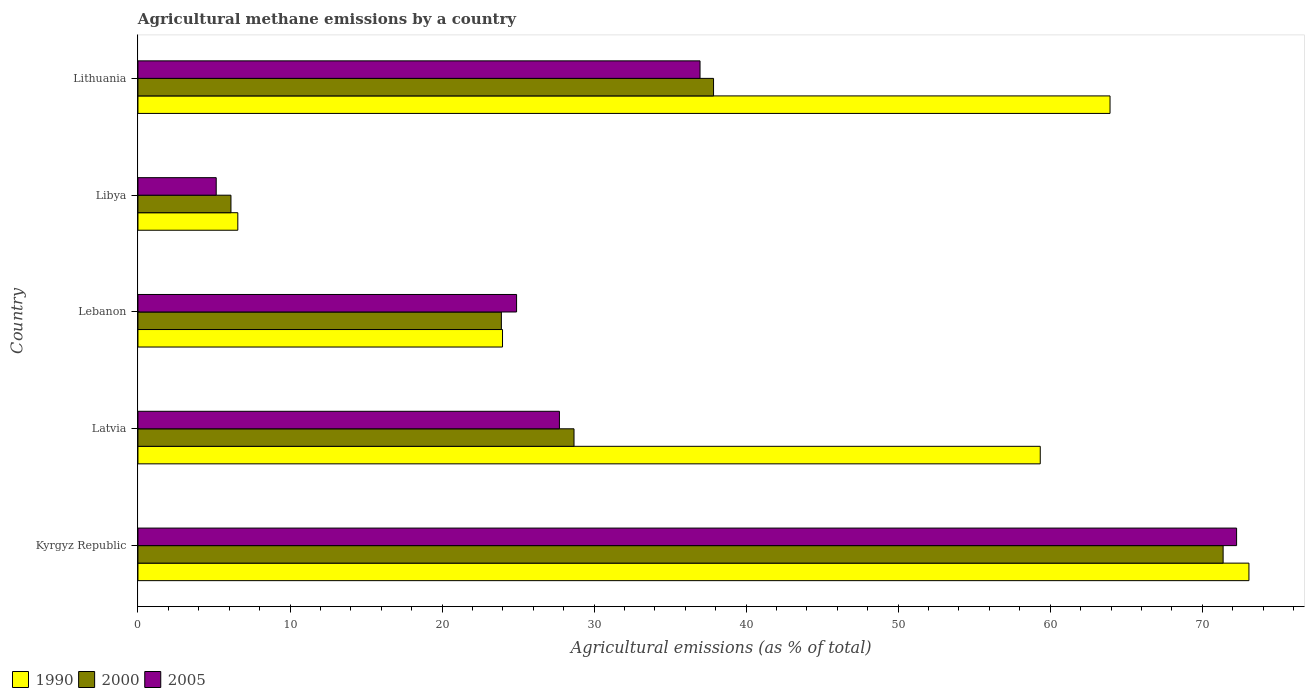How many different coloured bars are there?
Your answer should be very brief. 3. How many bars are there on the 4th tick from the bottom?
Provide a succinct answer. 3. What is the label of the 3rd group of bars from the top?
Make the answer very short. Lebanon. In how many cases, is the number of bars for a given country not equal to the number of legend labels?
Offer a very short reply. 0. What is the amount of agricultural methane emitted in 2000 in Latvia?
Your answer should be compact. 28.68. Across all countries, what is the maximum amount of agricultural methane emitted in 2000?
Ensure brevity in your answer.  71.37. Across all countries, what is the minimum amount of agricultural methane emitted in 2005?
Make the answer very short. 5.15. In which country was the amount of agricultural methane emitted in 1990 maximum?
Keep it short and to the point. Kyrgyz Republic. In which country was the amount of agricultural methane emitted in 2005 minimum?
Provide a succinct answer. Libya. What is the total amount of agricultural methane emitted in 2000 in the graph?
Your response must be concise. 167.93. What is the difference between the amount of agricultural methane emitted in 2000 in Lebanon and that in Lithuania?
Provide a succinct answer. -13.95. What is the difference between the amount of agricultural methane emitted in 1990 in Lithuania and the amount of agricultural methane emitted in 2005 in Latvia?
Make the answer very short. 36.21. What is the average amount of agricultural methane emitted in 1990 per country?
Offer a very short reply. 45.38. What is the difference between the amount of agricultural methane emitted in 2005 and amount of agricultural methane emitted in 1990 in Lebanon?
Offer a terse response. 0.93. In how many countries, is the amount of agricultural methane emitted in 2005 greater than 62 %?
Your response must be concise. 1. What is the ratio of the amount of agricultural methane emitted in 2000 in Kyrgyz Republic to that in Lithuania?
Your answer should be compact. 1.89. Is the difference between the amount of agricultural methane emitted in 2005 in Libya and Lithuania greater than the difference between the amount of agricultural methane emitted in 1990 in Libya and Lithuania?
Your response must be concise. Yes. What is the difference between the highest and the second highest amount of agricultural methane emitted in 2005?
Ensure brevity in your answer.  35.29. What is the difference between the highest and the lowest amount of agricultural methane emitted in 2005?
Ensure brevity in your answer.  67.11. In how many countries, is the amount of agricultural methane emitted in 1990 greater than the average amount of agricultural methane emitted in 1990 taken over all countries?
Give a very brief answer. 3. What does the 1st bar from the top in Latvia represents?
Your answer should be compact. 2005. What does the 1st bar from the bottom in Lithuania represents?
Keep it short and to the point. 1990. Is it the case that in every country, the sum of the amount of agricultural methane emitted in 2000 and amount of agricultural methane emitted in 2005 is greater than the amount of agricultural methane emitted in 1990?
Your answer should be very brief. No. How many bars are there?
Provide a short and direct response. 15. Are the values on the major ticks of X-axis written in scientific E-notation?
Your answer should be compact. No. Where does the legend appear in the graph?
Offer a terse response. Bottom left. How many legend labels are there?
Provide a short and direct response. 3. What is the title of the graph?
Provide a short and direct response. Agricultural methane emissions by a country. Does "1993" appear as one of the legend labels in the graph?
Give a very brief answer. No. What is the label or title of the X-axis?
Make the answer very short. Agricultural emissions (as % of total). What is the Agricultural emissions (as % of total) of 1990 in Kyrgyz Republic?
Provide a succinct answer. 73.07. What is the Agricultural emissions (as % of total) of 2000 in Kyrgyz Republic?
Ensure brevity in your answer.  71.37. What is the Agricultural emissions (as % of total) of 2005 in Kyrgyz Republic?
Your answer should be compact. 72.26. What is the Agricultural emissions (as % of total) in 1990 in Latvia?
Your answer should be very brief. 59.34. What is the Agricultural emissions (as % of total) in 2000 in Latvia?
Your answer should be very brief. 28.68. What is the Agricultural emissions (as % of total) in 2005 in Latvia?
Offer a terse response. 27.72. What is the Agricultural emissions (as % of total) of 1990 in Lebanon?
Provide a short and direct response. 23.98. What is the Agricultural emissions (as % of total) of 2000 in Lebanon?
Your response must be concise. 23.9. What is the Agricultural emissions (as % of total) in 2005 in Lebanon?
Provide a short and direct response. 24.9. What is the Agricultural emissions (as % of total) in 1990 in Libya?
Offer a very short reply. 6.57. What is the Agricultural emissions (as % of total) in 2000 in Libya?
Keep it short and to the point. 6.12. What is the Agricultural emissions (as % of total) of 2005 in Libya?
Ensure brevity in your answer.  5.15. What is the Agricultural emissions (as % of total) in 1990 in Lithuania?
Keep it short and to the point. 63.93. What is the Agricultural emissions (as % of total) in 2000 in Lithuania?
Make the answer very short. 37.86. What is the Agricultural emissions (as % of total) in 2005 in Lithuania?
Offer a very short reply. 36.97. Across all countries, what is the maximum Agricultural emissions (as % of total) of 1990?
Provide a succinct answer. 73.07. Across all countries, what is the maximum Agricultural emissions (as % of total) of 2000?
Your response must be concise. 71.37. Across all countries, what is the maximum Agricultural emissions (as % of total) in 2005?
Offer a terse response. 72.26. Across all countries, what is the minimum Agricultural emissions (as % of total) in 1990?
Offer a very short reply. 6.57. Across all countries, what is the minimum Agricultural emissions (as % of total) of 2000?
Give a very brief answer. 6.12. Across all countries, what is the minimum Agricultural emissions (as % of total) in 2005?
Give a very brief answer. 5.15. What is the total Agricultural emissions (as % of total) of 1990 in the graph?
Provide a short and direct response. 226.89. What is the total Agricultural emissions (as % of total) in 2000 in the graph?
Your answer should be compact. 167.93. What is the total Agricultural emissions (as % of total) in 2005 in the graph?
Your answer should be very brief. 167. What is the difference between the Agricultural emissions (as % of total) of 1990 in Kyrgyz Republic and that in Latvia?
Give a very brief answer. 13.73. What is the difference between the Agricultural emissions (as % of total) in 2000 in Kyrgyz Republic and that in Latvia?
Provide a succinct answer. 42.69. What is the difference between the Agricultural emissions (as % of total) of 2005 in Kyrgyz Republic and that in Latvia?
Your response must be concise. 44.54. What is the difference between the Agricultural emissions (as % of total) in 1990 in Kyrgyz Republic and that in Lebanon?
Ensure brevity in your answer.  49.09. What is the difference between the Agricultural emissions (as % of total) in 2000 in Kyrgyz Republic and that in Lebanon?
Provide a short and direct response. 47.47. What is the difference between the Agricultural emissions (as % of total) of 2005 in Kyrgyz Republic and that in Lebanon?
Make the answer very short. 47.36. What is the difference between the Agricultural emissions (as % of total) in 1990 in Kyrgyz Republic and that in Libya?
Offer a terse response. 66.5. What is the difference between the Agricultural emissions (as % of total) of 2000 in Kyrgyz Republic and that in Libya?
Your response must be concise. 65.26. What is the difference between the Agricultural emissions (as % of total) of 2005 in Kyrgyz Republic and that in Libya?
Offer a very short reply. 67.11. What is the difference between the Agricultural emissions (as % of total) in 1990 in Kyrgyz Republic and that in Lithuania?
Your response must be concise. 9.14. What is the difference between the Agricultural emissions (as % of total) in 2000 in Kyrgyz Republic and that in Lithuania?
Ensure brevity in your answer.  33.52. What is the difference between the Agricultural emissions (as % of total) of 2005 in Kyrgyz Republic and that in Lithuania?
Provide a succinct answer. 35.29. What is the difference between the Agricultural emissions (as % of total) of 1990 in Latvia and that in Lebanon?
Keep it short and to the point. 35.37. What is the difference between the Agricultural emissions (as % of total) of 2000 in Latvia and that in Lebanon?
Provide a short and direct response. 4.78. What is the difference between the Agricultural emissions (as % of total) in 2005 in Latvia and that in Lebanon?
Keep it short and to the point. 2.82. What is the difference between the Agricultural emissions (as % of total) of 1990 in Latvia and that in Libya?
Your response must be concise. 52.78. What is the difference between the Agricultural emissions (as % of total) in 2000 in Latvia and that in Libya?
Your response must be concise. 22.56. What is the difference between the Agricultural emissions (as % of total) of 2005 in Latvia and that in Libya?
Provide a short and direct response. 22.57. What is the difference between the Agricultural emissions (as % of total) in 1990 in Latvia and that in Lithuania?
Offer a very short reply. -4.59. What is the difference between the Agricultural emissions (as % of total) of 2000 in Latvia and that in Lithuania?
Offer a very short reply. -9.18. What is the difference between the Agricultural emissions (as % of total) of 2005 in Latvia and that in Lithuania?
Offer a terse response. -9.25. What is the difference between the Agricultural emissions (as % of total) in 1990 in Lebanon and that in Libya?
Your answer should be very brief. 17.41. What is the difference between the Agricultural emissions (as % of total) of 2000 in Lebanon and that in Libya?
Offer a very short reply. 17.79. What is the difference between the Agricultural emissions (as % of total) in 2005 in Lebanon and that in Libya?
Give a very brief answer. 19.76. What is the difference between the Agricultural emissions (as % of total) in 1990 in Lebanon and that in Lithuania?
Keep it short and to the point. -39.96. What is the difference between the Agricultural emissions (as % of total) of 2000 in Lebanon and that in Lithuania?
Offer a very short reply. -13.95. What is the difference between the Agricultural emissions (as % of total) in 2005 in Lebanon and that in Lithuania?
Your answer should be very brief. -12.07. What is the difference between the Agricultural emissions (as % of total) in 1990 in Libya and that in Lithuania?
Ensure brevity in your answer.  -57.37. What is the difference between the Agricultural emissions (as % of total) in 2000 in Libya and that in Lithuania?
Keep it short and to the point. -31.74. What is the difference between the Agricultural emissions (as % of total) of 2005 in Libya and that in Lithuania?
Your answer should be very brief. -31.82. What is the difference between the Agricultural emissions (as % of total) of 1990 in Kyrgyz Republic and the Agricultural emissions (as % of total) of 2000 in Latvia?
Your answer should be very brief. 44.39. What is the difference between the Agricultural emissions (as % of total) in 1990 in Kyrgyz Republic and the Agricultural emissions (as % of total) in 2005 in Latvia?
Your response must be concise. 45.35. What is the difference between the Agricultural emissions (as % of total) in 2000 in Kyrgyz Republic and the Agricultural emissions (as % of total) in 2005 in Latvia?
Your answer should be compact. 43.65. What is the difference between the Agricultural emissions (as % of total) of 1990 in Kyrgyz Republic and the Agricultural emissions (as % of total) of 2000 in Lebanon?
Ensure brevity in your answer.  49.17. What is the difference between the Agricultural emissions (as % of total) in 1990 in Kyrgyz Republic and the Agricultural emissions (as % of total) in 2005 in Lebanon?
Offer a terse response. 48.17. What is the difference between the Agricultural emissions (as % of total) in 2000 in Kyrgyz Republic and the Agricultural emissions (as % of total) in 2005 in Lebanon?
Give a very brief answer. 46.47. What is the difference between the Agricultural emissions (as % of total) in 1990 in Kyrgyz Republic and the Agricultural emissions (as % of total) in 2000 in Libya?
Give a very brief answer. 66.95. What is the difference between the Agricultural emissions (as % of total) in 1990 in Kyrgyz Republic and the Agricultural emissions (as % of total) in 2005 in Libya?
Provide a succinct answer. 67.92. What is the difference between the Agricultural emissions (as % of total) of 2000 in Kyrgyz Republic and the Agricultural emissions (as % of total) of 2005 in Libya?
Provide a short and direct response. 66.23. What is the difference between the Agricultural emissions (as % of total) in 1990 in Kyrgyz Republic and the Agricultural emissions (as % of total) in 2000 in Lithuania?
Provide a short and direct response. 35.21. What is the difference between the Agricultural emissions (as % of total) in 1990 in Kyrgyz Republic and the Agricultural emissions (as % of total) in 2005 in Lithuania?
Give a very brief answer. 36.1. What is the difference between the Agricultural emissions (as % of total) of 2000 in Kyrgyz Republic and the Agricultural emissions (as % of total) of 2005 in Lithuania?
Provide a succinct answer. 34.4. What is the difference between the Agricultural emissions (as % of total) of 1990 in Latvia and the Agricultural emissions (as % of total) of 2000 in Lebanon?
Keep it short and to the point. 35.44. What is the difference between the Agricultural emissions (as % of total) of 1990 in Latvia and the Agricultural emissions (as % of total) of 2005 in Lebanon?
Keep it short and to the point. 34.44. What is the difference between the Agricultural emissions (as % of total) of 2000 in Latvia and the Agricultural emissions (as % of total) of 2005 in Lebanon?
Offer a very short reply. 3.78. What is the difference between the Agricultural emissions (as % of total) in 1990 in Latvia and the Agricultural emissions (as % of total) in 2000 in Libya?
Keep it short and to the point. 53.23. What is the difference between the Agricultural emissions (as % of total) of 1990 in Latvia and the Agricultural emissions (as % of total) of 2005 in Libya?
Offer a terse response. 54.2. What is the difference between the Agricultural emissions (as % of total) of 2000 in Latvia and the Agricultural emissions (as % of total) of 2005 in Libya?
Provide a short and direct response. 23.53. What is the difference between the Agricultural emissions (as % of total) in 1990 in Latvia and the Agricultural emissions (as % of total) in 2000 in Lithuania?
Offer a terse response. 21.49. What is the difference between the Agricultural emissions (as % of total) in 1990 in Latvia and the Agricultural emissions (as % of total) in 2005 in Lithuania?
Make the answer very short. 22.38. What is the difference between the Agricultural emissions (as % of total) of 2000 in Latvia and the Agricultural emissions (as % of total) of 2005 in Lithuania?
Give a very brief answer. -8.29. What is the difference between the Agricultural emissions (as % of total) in 1990 in Lebanon and the Agricultural emissions (as % of total) in 2000 in Libya?
Offer a terse response. 17.86. What is the difference between the Agricultural emissions (as % of total) of 1990 in Lebanon and the Agricultural emissions (as % of total) of 2005 in Libya?
Keep it short and to the point. 18.83. What is the difference between the Agricultural emissions (as % of total) in 2000 in Lebanon and the Agricultural emissions (as % of total) in 2005 in Libya?
Keep it short and to the point. 18.76. What is the difference between the Agricultural emissions (as % of total) of 1990 in Lebanon and the Agricultural emissions (as % of total) of 2000 in Lithuania?
Your answer should be compact. -13.88. What is the difference between the Agricultural emissions (as % of total) of 1990 in Lebanon and the Agricultural emissions (as % of total) of 2005 in Lithuania?
Keep it short and to the point. -12.99. What is the difference between the Agricultural emissions (as % of total) of 2000 in Lebanon and the Agricultural emissions (as % of total) of 2005 in Lithuania?
Give a very brief answer. -13.07. What is the difference between the Agricultural emissions (as % of total) in 1990 in Libya and the Agricultural emissions (as % of total) in 2000 in Lithuania?
Provide a succinct answer. -31.29. What is the difference between the Agricultural emissions (as % of total) in 1990 in Libya and the Agricultural emissions (as % of total) in 2005 in Lithuania?
Offer a terse response. -30.4. What is the difference between the Agricultural emissions (as % of total) of 2000 in Libya and the Agricultural emissions (as % of total) of 2005 in Lithuania?
Your answer should be very brief. -30.85. What is the average Agricultural emissions (as % of total) of 1990 per country?
Provide a succinct answer. 45.38. What is the average Agricultural emissions (as % of total) in 2000 per country?
Keep it short and to the point. 33.59. What is the average Agricultural emissions (as % of total) of 2005 per country?
Provide a succinct answer. 33.4. What is the difference between the Agricultural emissions (as % of total) in 1990 and Agricultural emissions (as % of total) in 2000 in Kyrgyz Republic?
Provide a short and direct response. 1.7. What is the difference between the Agricultural emissions (as % of total) in 1990 and Agricultural emissions (as % of total) in 2005 in Kyrgyz Republic?
Make the answer very short. 0.81. What is the difference between the Agricultural emissions (as % of total) of 2000 and Agricultural emissions (as % of total) of 2005 in Kyrgyz Republic?
Provide a succinct answer. -0.89. What is the difference between the Agricultural emissions (as % of total) of 1990 and Agricultural emissions (as % of total) of 2000 in Latvia?
Keep it short and to the point. 30.66. What is the difference between the Agricultural emissions (as % of total) in 1990 and Agricultural emissions (as % of total) in 2005 in Latvia?
Your response must be concise. 31.62. What is the difference between the Agricultural emissions (as % of total) in 2000 and Agricultural emissions (as % of total) in 2005 in Latvia?
Make the answer very short. 0.96. What is the difference between the Agricultural emissions (as % of total) of 1990 and Agricultural emissions (as % of total) of 2000 in Lebanon?
Ensure brevity in your answer.  0.07. What is the difference between the Agricultural emissions (as % of total) of 1990 and Agricultural emissions (as % of total) of 2005 in Lebanon?
Provide a succinct answer. -0.93. What is the difference between the Agricultural emissions (as % of total) in 2000 and Agricultural emissions (as % of total) in 2005 in Lebanon?
Your answer should be compact. -1. What is the difference between the Agricultural emissions (as % of total) in 1990 and Agricultural emissions (as % of total) in 2000 in Libya?
Ensure brevity in your answer.  0.45. What is the difference between the Agricultural emissions (as % of total) of 1990 and Agricultural emissions (as % of total) of 2005 in Libya?
Give a very brief answer. 1.42. What is the difference between the Agricultural emissions (as % of total) of 2000 and Agricultural emissions (as % of total) of 2005 in Libya?
Offer a terse response. 0.97. What is the difference between the Agricultural emissions (as % of total) of 1990 and Agricultural emissions (as % of total) of 2000 in Lithuania?
Provide a short and direct response. 26.08. What is the difference between the Agricultural emissions (as % of total) in 1990 and Agricultural emissions (as % of total) in 2005 in Lithuania?
Your answer should be compact. 26.97. What is the difference between the Agricultural emissions (as % of total) of 2000 and Agricultural emissions (as % of total) of 2005 in Lithuania?
Your answer should be very brief. 0.89. What is the ratio of the Agricultural emissions (as % of total) in 1990 in Kyrgyz Republic to that in Latvia?
Keep it short and to the point. 1.23. What is the ratio of the Agricultural emissions (as % of total) of 2000 in Kyrgyz Republic to that in Latvia?
Your answer should be compact. 2.49. What is the ratio of the Agricultural emissions (as % of total) in 2005 in Kyrgyz Republic to that in Latvia?
Give a very brief answer. 2.61. What is the ratio of the Agricultural emissions (as % of total) in 1990 in Kyrgyz Republic to that in Lebanon?
Give a very brief answer. 3.05. What is the ratio of the Agricultural emissions (as % of total) of 2000 in Kyrgyz Republic to that in Lebanon?
Ensure brevity in your answer.  2.99. What is the ratio of the Agricultural emissions (as % of total) of 2005 in Kyrgyz Republic to that in Lebanon?
Make the answer very short. 2.9. What is the ratio of the Agricultural emissions (as % of total) in 1990 in Kyrgyz Republic to that in Libya?
Offer a very short reply. 11.13. What is the ratio of the Agricultural emissions (as % of total) of 2000 in Kyrgyz Republic to that in Libya?
Offer a very short reply. 11.67. What is the ratio of the Agricultural emissions (as % of total) of 2005 in Kyrgyz Republic to that in Libya?
Offer a very short reply. 14.04. What is the ratio of the Agricultural emissions (as % of total) in 2000 in Kyrgyz Republic to that in Lithuania?
Ensure brevity in your answer.  1.89. What is the ratio of the Agricultural emissions (as % of total) in 2005 in Kyrgyz Republic to that in Lithuania?
Keep it short and to the point. 1.95. What is the ratio of the Agricultural emissions (as % of total) in 1990 in Latvia to that in Lebanon?
Your response must be concise. 2.48. What is the ratio of the Agricultural emissions (as % of total) of 2000 in Latvia to that in Lebanon?
Your response must be concise. 1.2. What is the ratio of the Agricultural emissions (as % of total) in 2005 in Latvia to that in Lebanon?
Provide a short and direct response. 1.11. What is the ratio of the Agricultural emissions (as % of total) in 1990 in Latvia to that in Libya?
Offer a very short reply. 9.04. What is the ratio of the Agricultural emissions (as % of total) of 2000 in Latvia to that in Libya?
Offer a very short reply. 4.69. What is the ratio of the Agricultural emissions (as % of total) of 2005 in Latvia to that in Libya?
Make the answer very short. 5.39. What is the ratio of the Agricultural emissions (as % of total) of 1990 in Latvia to that in Lithuania?
Give a very brief answer. 0.93. What is the ratio of the Agricultural emissions (as % of total) in 2000 in Latvia to that in Lithuania?
Provide a succinct answer. 0.76. What is the ratio of the Agricultural emissions (as % of total) in 2005 in Latvia to that in Lithuania?
Your answer should be compact. 0.75. What is the ratio of the Agricultural emissions (as % of total) in 1990 in Lebanon to that in Libya?
Your answer should be very brief. 3.65. What is the ratio of the Agricultural emissions (as % of total) in 2000 in Lebanon to that in Libya?
Make the answer very short. 3.91. What is the ratio of the Agricultural emissions (as % of total) of 2005 in Lebanon to that in Libya?
Your response must be concise. 4.84. What is the ratio of the Agricultural emissions (as % of total) in 1990 in Lebanon to that in Lithuania?
Offer a terse response. 0.38. What is the ratio of the Agricultural emissions (as % of total) in 2000 in Lebanon to that in Lithuania?
Give a very brief answer. 0.63. What is the ratio of the Agricultural emissions (as % of total) of 2005 in Lebanon to that in Lithuania?
Your answer should be compact. 0.67. What is the ratio of the Agricultural emissions (as % of total) in 1990 in Libya to that in Lithuania?
Your answer should be compact. 0.1. What is the ratio of the Agricultural emissions (as % of total) in 2000 in Libya to that in Lithuania?
Keep it short and to the point. 0.16. What is the ratio of the Agricultural emissions (as % of total) of 2005 in Libya to that in Lithuania?
Offer a very short reply. 0.14. What is the difference between the highest and the second highest Agricultural emissions (as % of total) in 1990?
Offer a terse response. 9.14. What is the difference between the highest and the second highest Agricultural emissions (as % of total) in 2000?
Give a very brief answer. 33.52. What is the difference between the highest and the second highest Agricultural emissions (as % of total) of 2005?
Your answer should be very brief. 35.29. What is the difference between the highest and the lowest Agricultural emissions (as % of total) of 1990?
Provide a succinct answer. 66.5. What is the difference between the highest and the lowest Agricultural emissions (as % of total) of 2000?
Keep it short and to the point. 65.26. What is the difference between the highest and the lowest Agricultural emissions (as % of total) in 2005?
Your answer should be compact. 67.11. 